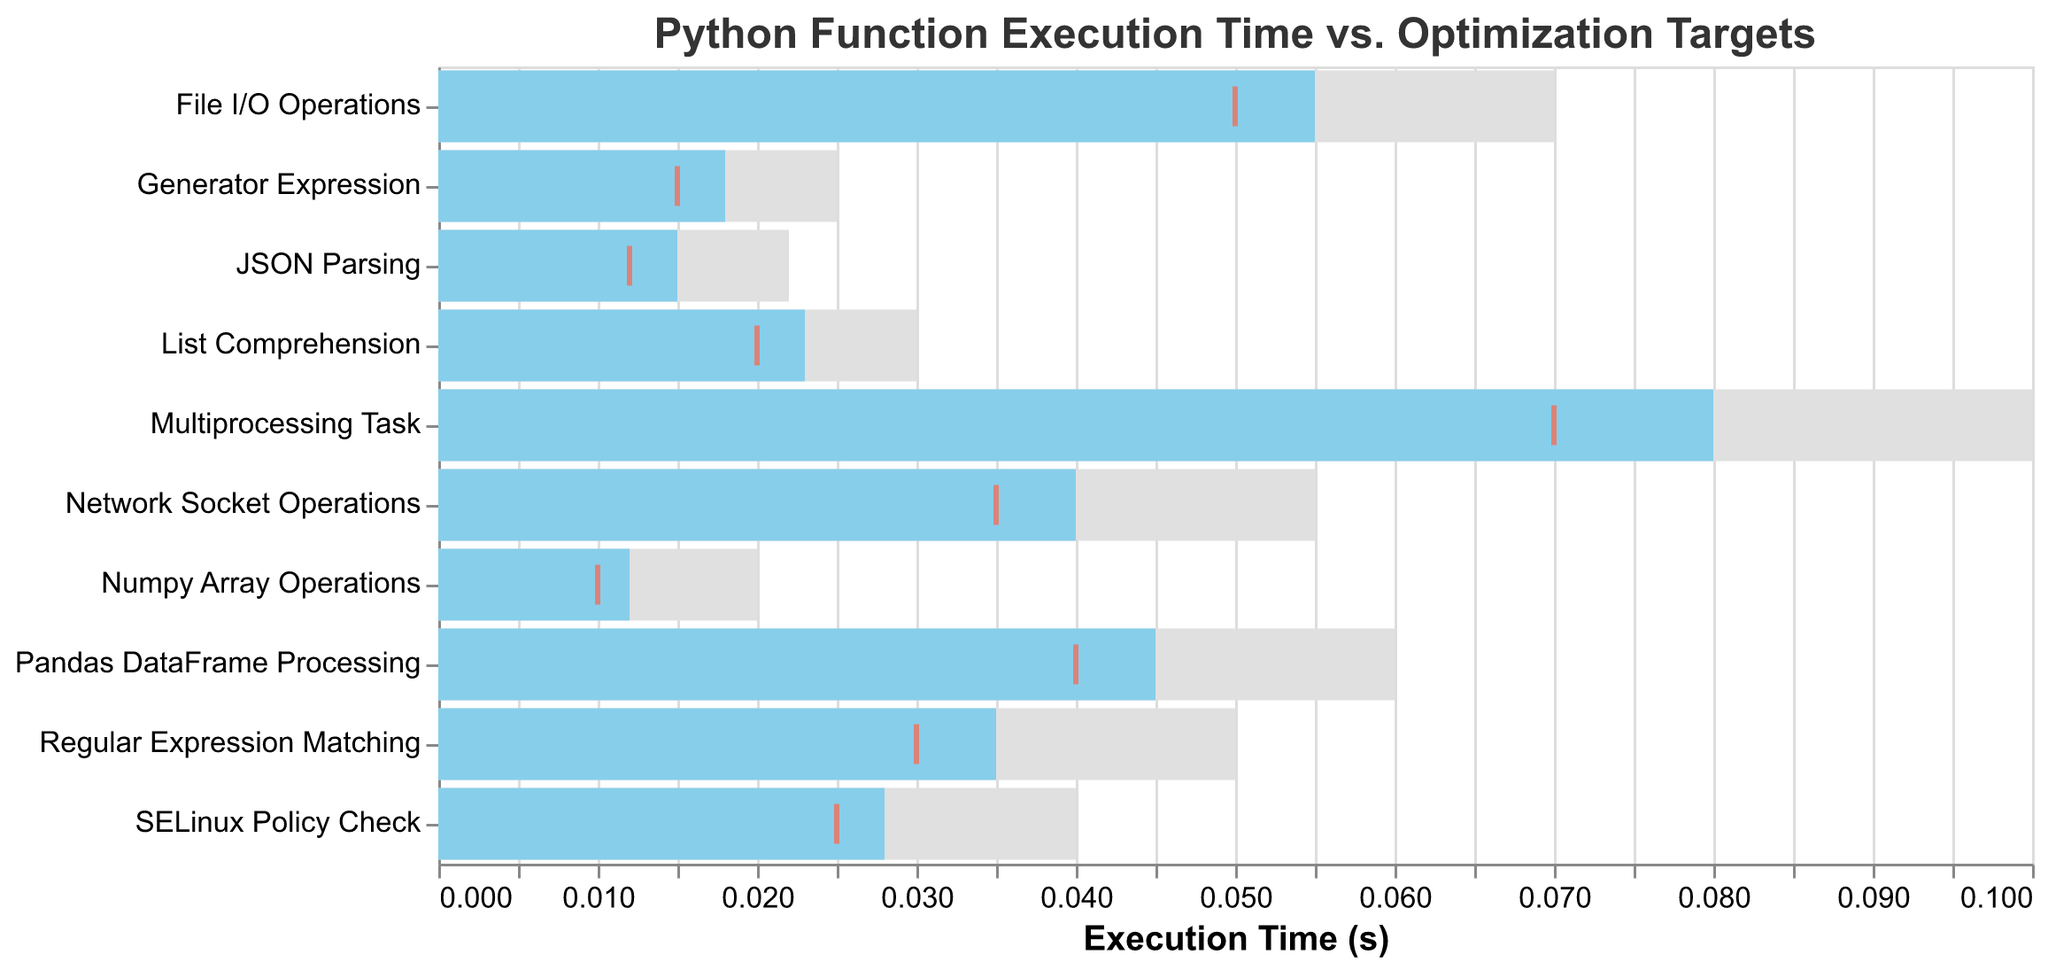What is the title of the plot? The title is usually displayed at the top of the plot. In this case, the title specifies what the plot is about. Here it is "Python Function Execution Time vs. Optimization Targets".
Answer: Python Function Execution Time vs. Optimization Targets How many functions are displayed in the plot? Count the number of different function names listed on the y-axis of the plot. Each function represents a data point on the chart.
Answer: 10 Which function has the highest actual execution time? Identify the function with the longest blue bar, representing the actual execution time. The Multiprocessing Task has the longest blue bar.
Answer: Multiprocessing Task What color represents the actual execution time bars? Inspect the color of the bars that indicate actual execution times. In the plot, these bars are colored light blue.
Answer: light blue Which function meets its target execution time? Compare the actual execution time bars (light blue) with the tick marks (red) indicating the target execution times. A function meets its target if the blue bar is equal to or shorter than the red tick mark.
Answer: JSON Parsing For which function is the difference between actual and maximum execution time the largest? To determine the difference, subtract the actual execution time from the maximum execution time for each function. The function with the largest difference is Multiprocessing Task: 0.100 - 0.080 = 0.020.
Answer: Multiprocessing Task Which functions have actual execution times exceeding their target times by more than 0.005 seconds? Calculate the difference between actual and target execution times for each function. List those functions where the difference is greater than 0.005 seconds. These functions are File I/O Operations, Pandas DataFrame Processing, and Network Socket Operations.
Answer: File I/O Operations, Pandas DataFrame Processing, Network Socket Operations In which function is the actual execution time closest to the target execution time? Identify the function where the absolute difference between the actual and target times is the smallest. This is for SELinux Policy Check:
Answer: SELinux Policy Check What is the average target execution time of all the functions? Sum all the target execution times and divide by the number of functions (10). The total is \(0.020 + 0.015 + 0.010 + 0.040 + 0.030 + 0.050 + 0.025 + 0.012 + 0.035 + 0.070\). This sums to 0.307. Thus the average is \(0.307 / 10 = 0.0307\).
Answer: 0.0307 Which function has the widest gap between target and maximum execution times? To find the widest gap, subtract the target execution time from the maximum execution time for each function. The function with the largest difference: Multiprocessing Task 0.100 - 0.070 = 0.030.
Answer: Multiprocessing Task 